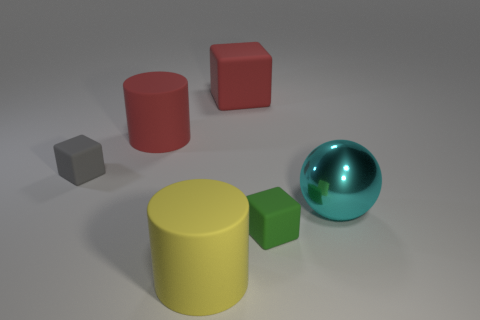What shape is the matte object that is in front of the large cyan thing and to the left of the small green matte cube?
Your answer should be very brief. Cylinder. Are there any small gray things that have the same material as the yellow cylinder?
Offer a terse response. Yes. What is the color of the small matte block that is in front of the gray block?
Ensure brevity in your answer.  Green. Is the shape of the yellow matte object the same as the large red rubber object on the left side of the big rubber block?
Your answer should be compact. Yes. Is there a thing of the same color as the large block?
Your answer should be compact. Yes. There is a green object that is made of the same material as the small gray cube; what is its size?
Your answer should be very brief. Small. There is a small rubber thing in front of the big cyan metal thing; is it the same shape as the gray object?
Give a very brief answer. Yes. How many green things have the same size as the cyan thing?
Your response must be concise. 0. The rubber thing that is the same color as the large matte block is what shape?
Offer a terse response. Cylinder. Is there a red object on the left side of the large object in front of the big cyan object?
Your answer should be compact. Yes. 